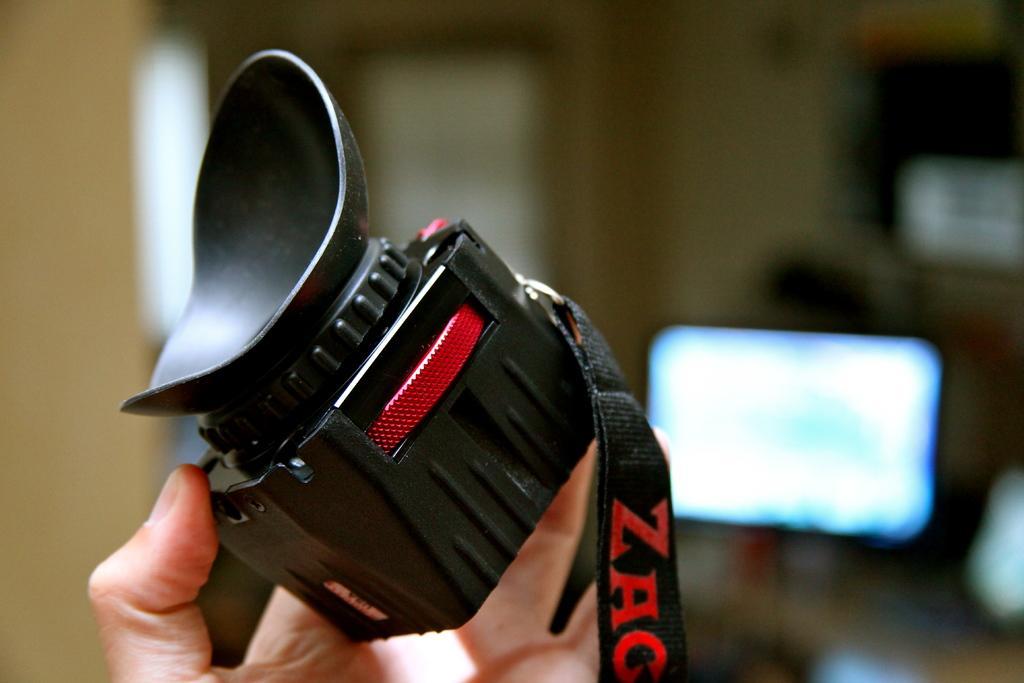In one or two sentences, can you explain what this image depicts? In the picture we can see a person's hand holding a camera which is black in color with a black color tag and a screen to it and in the background it is invisible. 